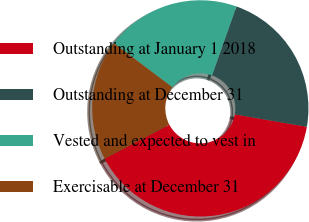Convert chart to OTSL. <chart><loc_0><loc_0><loc_500><loc_500><pie_chart><fcel>Outstanding at January 1 2018<fcel>Outstanding at December 31<fcel>Vested and expected to vest in<fcel>Exercisable at December 31<nl><fcel>39.58%<fcel>22.3%<fcel>20.14%<fcel>17.98%<nl></chart> 